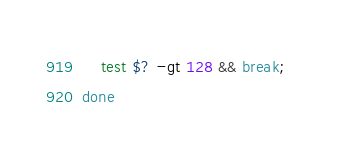Convert code to text. <code><loc_0><loc_0><loc_500><loc_500><_Bash_>    test $? -gt 128 && break; 
done</code> 